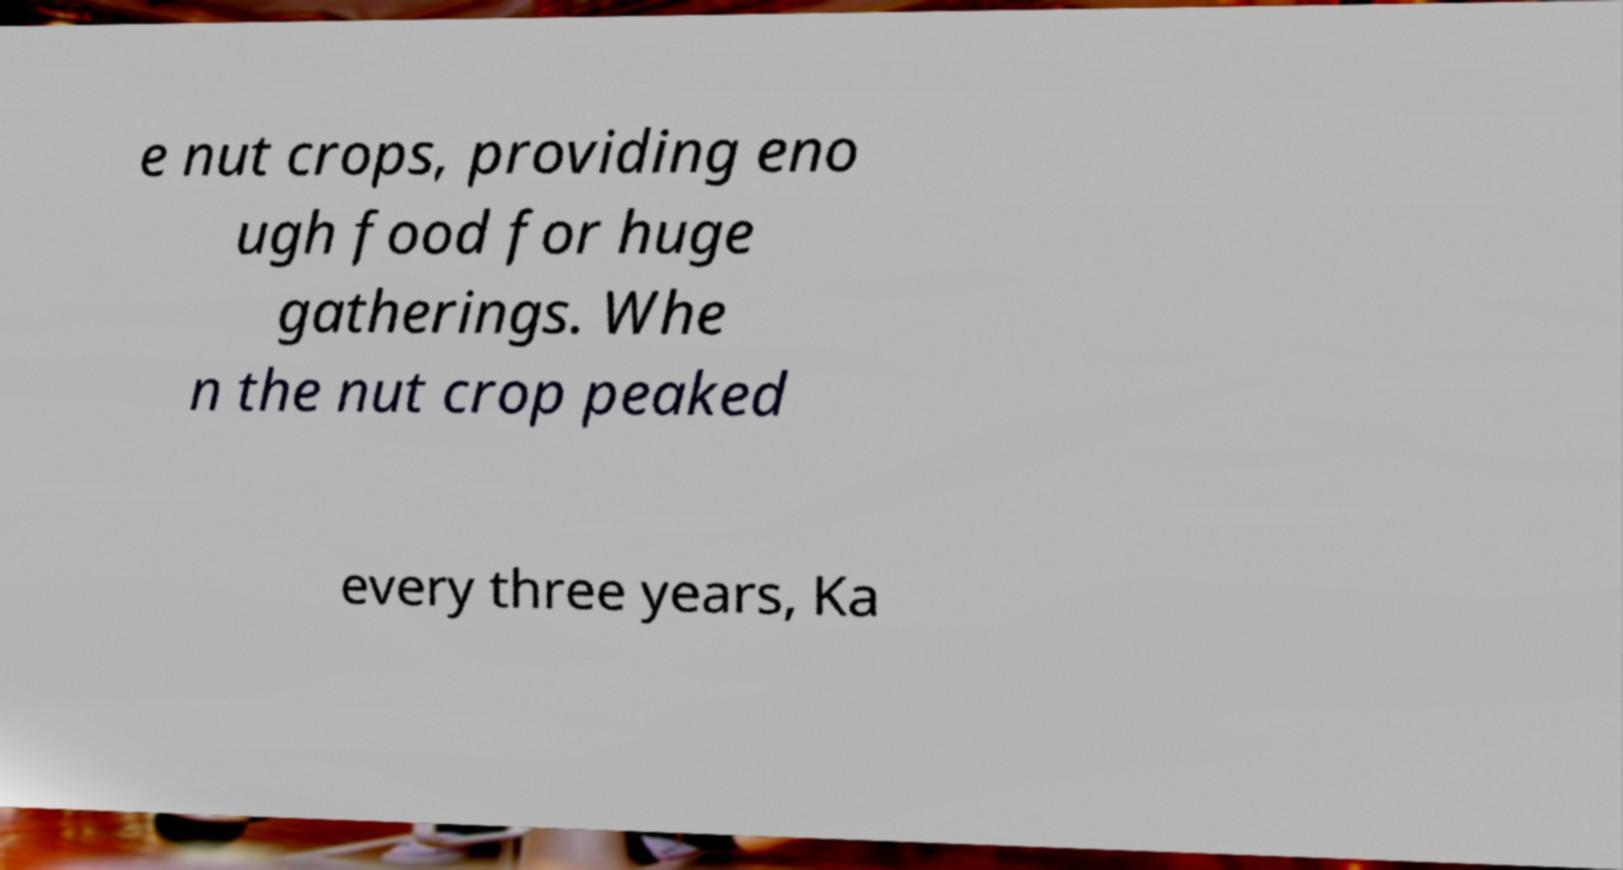Could you extract and type out the text from this image? e nut crops, providing eno ugh food for huge gatherings. Whe n the nut crop peaked every three years, Ka 